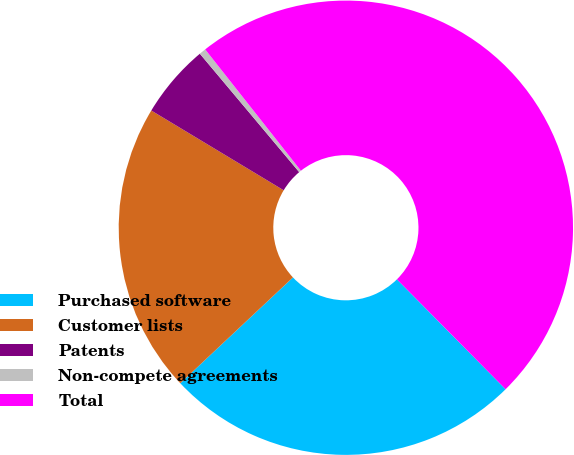Convert chart. <chart><loc_0><loc_0><loc_500><loc_500><pie_chart><fcel>Purchased software<fcel>Customer lists<fcel>Patents<fcel>Non-compete agreements<fcel>Total<nl><fcel>25.41%<fcel>20.63%<fcel>5.26%<fcel>0.48%<fcel>48.22%<nl></chart> 